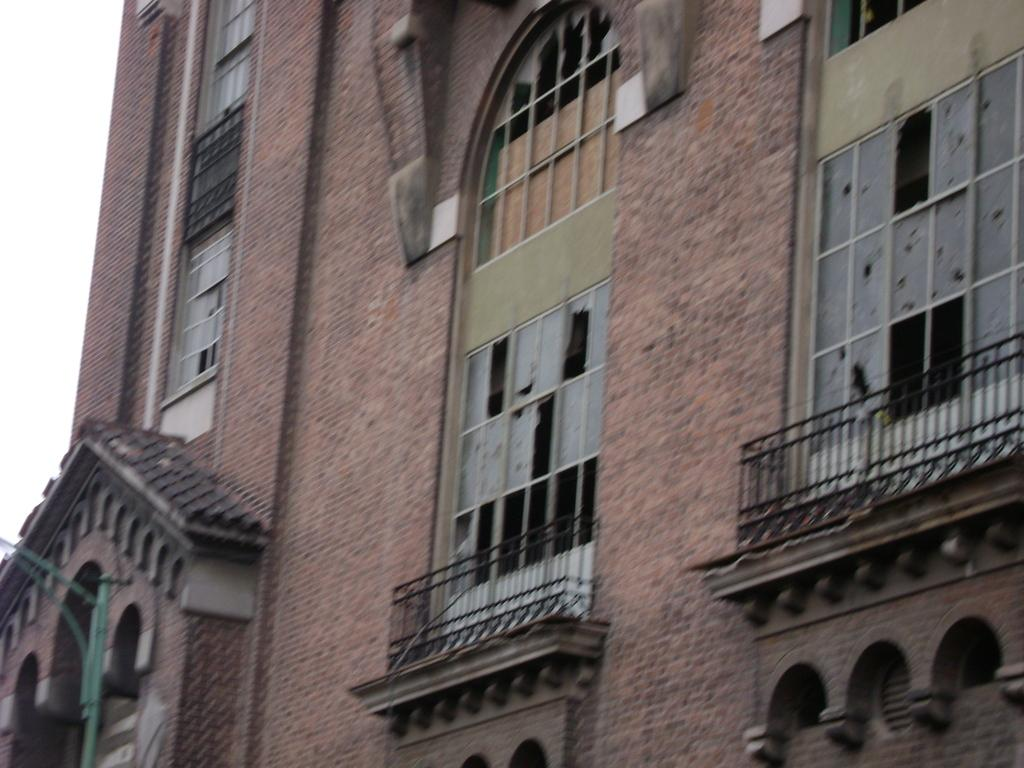What type of structure is visible in the image? There is a building in the image. What is the color of the building? The building is brown in color. What features can be seen on the building? The building has windows and railing. What is visible in the background of the image? The sky is white in the image. Can you see the zebra's neck in the image? There is no zebra present in the image, so it is not possible to see its neck. 